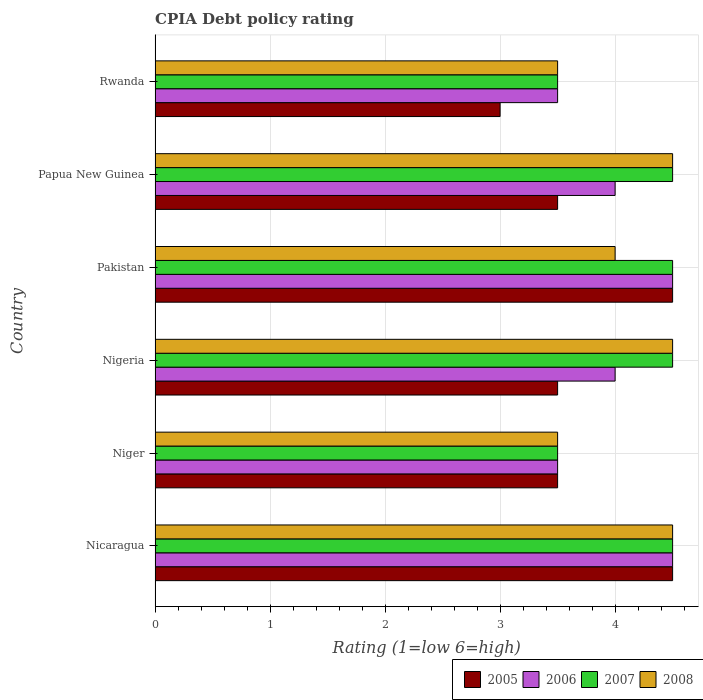How many groups of bars are there?
Provide a short and direct response. 6. Are the number of bars per tick equal to the number of legend labels?
Your answer should be very brief. Yes. Are the number of bars on each tick of the Y-axis equal?
Keep it short and to the point. Yes. How many bars are there on the 4th tick from the top?
Ensure brevity in your answer.  4. What is the label of the 1st group of bars from the top?
Offer a very short reply. Rwanda. In how many cases, is the number of bars for a given country not equal to the number of legend labels?
Your answer should be compact. 0. Across all countries, what is the minimum CPIA rating in 2005?
Your answer should be compact. 3. In which country was the CPIA rating in 2007 maximum?
Your answer should be very brief. Nicaragua. In which country was the CPIA rating in 2006 minimum?
Provide a succinct answer. Niger. What is the average CPIA rating in 2008 per country?
Make the answer very short. 4.08. What is the difference between the CPIA rating in 2006 and CPIA rating in 2005 in Nicaragua?
Provide a succinct answer. 0. In how many countries, is the CPIA rating in 2006 greater than 0.2 ?
Offer a very short reply. 6. What is the ratio of the CPIA rating in 2006 in Papua New Guinea to that in Rwanda?
Make the answer very short. 1.14. Is the CPIA rating in 2006 in Nicaragua less than that in Papua New Guinea?
Make the answer very short. No. Is the difference between the CPIA rating in 2006 in Nigeria and Pakistan greater than the difference between the CPIA rating in 2005 in Nigeria and Pakistan?
Your answer should be compact. Yes. What is the difference between the highest and the lowest CPIA rating in 2007?
Ensure brevity in your answer.  1. Is the sum of the CPIA rating in 2005 in Niger and Nigeria greater than the maximum CPIA rating in 2007 across all countries?
Keep it short and to the point. Yes. What does the 1st bar from the top in Niger represents?
Your answer should be compact. 2008. What does the 4th bar from the bottom in Nigeria represents?
Keep it short and to the point. 2008. Is it the case that in every country, the sum of the CPIA rating in 2006 and CPIA rating in 2007 is greater than the CPIA rating in 2005?
Make the answer very short. Yes. Are all the bars in the graph horizontal?
Your answer should be very brief. Yes. How many countries are there in the graph?
Offer a terse response. 6. Does the graph contain any zero values?
Your response must be concise. No. Where does the legend appear in the graph?
Keep it short and to the point. Bottom right. What is the title of the graph?
Offer a very short reply. CPIA Debt policy rating. What is the label or title of the X-axis?
Give a very brief answer. Rating (1=low 6=high). What is the Rating (1=low 6=high) in 2005 in Nigeria?
Make the answer very short. 3.5. What is the Rating (1=low 6=high) of 2007 in Nigeria?
Provide a short and direct response. 4.5. What is the Rating (1=low 6=high) of 2006 in Pakistan?
Ensure brevity in your answer.  4.5. What is the Rating (1=low 6=high) in 2007 in Pakistan?
Ensure brevity in your answer.  4.5. What is the Rating (1=low 6=high) in 2007 in Papua New Guinea?
Make the answer very short. 4.5. What is the Rating (1=low 6=high) in 2006 in Rwanda?
Provide a succinct answer. 3.5. What is the Rating (1=low 6=high) of 2007 in Rwanda?
Ensure brevity in your answer.  3.5. Across all countries, what is the maximum Rating (1=low 6=high) in 2005?
Your answer should be very brief. 4.5. Across all countries, what is the maximum Rating (1=low 6=high) in 2006?
Keep it short and to the point. 4.5. Across all countries, what is the maximum Rating (1=low 6=high) in 2007?
Provide a short and direct response. 4.5. Across all countries, what is the maximum Rating (1=low 6=high) of 2008?
Give a very brief answer. 4.5. Across all countries, what is the minimum Rating (1=low 6=high) in 2005?
Make the answer very short. 3. Across all countries, what is the minimum Rating (1=low 6=high) in 2006?
Your answer should be compact. 3.5. Across all countries, what is the minimum Rating (1=low 6=high) in 2007?
Your answer should be very brief. 3.5. Across all countries, what is the minimum Rating (1=low 6=high) of 2008?
Your answer should be very brief. 3.5. What is the total Rating (1=low 6=high) of 2006 in the graph?
Provide a succinct answer. 24. What is the total Rating (1=low 6=high) in 2007 in the graph?
Provide a succinct answer. 25. What is the difference between the Rating (1=low 6=high) in 2005 in Nicaragua and that in Niger?
Your response must be concise. 1. What is the difference between the Rating (1=low 6=high) in 2007 in Nicaragua and that in Niger?
Give a very brief answer. 1. What is the difference between the Rating (1=low 6=high) in 2006 in Nicaragua and that in Nigeria?
Your answer should be compact. 0.5. What is the difference between the Rating (1=low 6=high) in 2008 in Nicaragua and that in Nigeria?
Ensure brevity in your answer.  0. What is the difference between the Rating (1=low 6=high) in 2006 in Nicaragua and that in Pakistan?
Keep it short and to the point. 0. What is the difference between the Rating (1=low 6=high) of 2007 in Nicaragua and that in Pakistan?
Keep it short and to the point. 0. What is the difference between the Rating (1=low 6=high) of 2008 in Nicaragua and that in Pakistan?
Keep it short and to the point. 0.5. What is the difference between the Rating (1=low 6=high) in 2005 in Nicaragua and that in Papua New Guinea?
Provide a short and direct response. 1. What is the difference between the Rating (1=low 6=high) of 2008 in Nicaragua and that in Papua New Guinea?
Make the answer very short. 0. What is the difference between the Rating (1=low 6=high) in 2005 in Nicaragua and that in Rwanda?
Provide a succinct answer. 1.5. What is the difference between the Rating (1=low 6=high) of 2007 in Nicaragua and that in Rwanda?
Your response must be concise. 1. What is the difference between the Rating (1=low 6=high) in 2008 in Nicaragua and that in Rwanda?
Give a very brief answer. 1. What is the difference between the Rating (1=low 6=high) of 2006 in Niger and that in Nigeria?
Your response must be concise. -0.5. What is the difference between the Rating (1=low 6=high) of 2008 in Niger and that in Nigeria?
Your answer should be very brief. -1. What is the difference between the Rating (1=low 6=high) in 2006 in Niger and that in Pakistan?
Provide a short and direct response. -1. What is the difference between the Rating (1=low 6=high) of 2007 in Niger and that in Pakistan?
Your answer should be very brief. -1. What is the difference between the Rating (1=low 6=high) of 2006 in Niger and that in Papua New Guinea?
Provide a short and direct response. -0.5. What is the difference between the Rating (1=low 6=high) of 2007 in Niger and that in Papua New Guinea?
Provide a succinct answer. -1. What is the difference between the Rating (1=low 6=high) in 2005 in Niger and that in Rwanda?
Offer a terse response. 0.5. What is the difference between the Rating (1=low 6=high) of 2007 in Niger and that in Rwanda?
Ensure brevity in your answer.  0. What is the difference between the Rating (1=low 6=high) of 2006 in Nigeria and that in Pakistan?
Ensure brevity in your answer.  -0.5. What is the difference between the Rating (1=low 6=high) of 2007 in Nigeria and that in Pakistan?
Provide a short and direct response. 0. What is the difference between the Rating (1=low 6=high) of 2008 in Nigeria and that in Pakistan?
Your answer should be compact. 0.5. What is the difference between the Rating (1=low 6=high) in 2007 in Nigeria and that in Papua New Guinea?
Keep it short and to the point. 0. What is the difference between the Rating (1=low 6=high) of 2008 in Nigeria and that in Papua New Guinea?
Give a very brief answer. 0. What is the difference between the Rating (1=low 6=high) of 2005 in Nigeria and that in Rwanda?
Offer a terse response. 0.5. What is the difference between the Rating (1=low 6=high) in 2006 in Nigeria and that in Rwanda?
Keep it short and to the point. 0.5. What is the difference between the Rating (1=low 6=high) of 2007 in Nigeria and that in Rwanda?
Ensure brevity in your answer.  1. What is the difference between the Rating (1=low 6=high) of 2008 in Nigeria and that in Rwanda?
Offer a terse response. 1. What is the difference between the Rating (1=low 6=high) of 2007 in Pakistan and that in Papua New Guinea?
Keep it short and to the point. 0. What is the difference between the Rating (1=low 6=high) in 2008 in Pakistan and that in Papua New Guinea?
Make the answer very short. -0.5. What is the difference between the Rating (1=low 6=high) in 2005 in Pakistan and that in Rwanda?
Your answer should be very brief. 1.5. What is the difference between the Rating (1=low 6=high) of 2006 in Pakistan and that in Rwanda?
Offer a terse response. 1. What is the difference between the Rating (1=low 6=high) in 2007 in Pakistan and that in Rwanda?
Keep it short and to the point. 1. What is the difference between the Rating (1=low 6=high) in 2008 in Pakistan and that in Rwanda?
Ensure brevity in your answer.  0.5. What is the difference between the Rating (1=low 6=high) in 2006 in Papua New Guinea and that in Rwanda?
Offer a terse response. 0.5. What is the difference between the Rating (1=low 6=high) of 2007 in Papua New Guinea and that in Rwanda?
Offer a terse response. 1. What is the difference between the Rating (1=low 6=high) in 2008 in Papua New Guinea and that in Rwanda?
Give a very brief answer. 1. What is the difference between the Rating (1=low 6=high) of 2005 in Nicaragua and the Rating (1=low 6=high) of 2007 in Niger?
Provide a short and direct response. 1. What is the difference between the Rating (1=low 6=high) in 2005 in Nicaragua and the Rating (1=low 6=high) in 2008 in Niger?
Your answer should be very brief. 1. What is the difference between the Rating (1=low 6=high) in 2006 in Nicaragua and the Rating (1=low 6=high) in 2007 in Niger?
Ensure brevity in your answer.  1. What is the difference between the Rating (1=low 6=high) in 2007 in Nicaragua and the Rating (1=low 6=high) in 2008 in Niger?
Your answer should be compact. 1. What is the difference between the Rating (1=low 6=high) of 2005 in Nicaragua and the Rating (1=low 6=high) of 2008 in Nigeria?
Provide a short and direct response. 0. What is the difference between the Rating (1=low 6=high) in 2006 in Nicaragua and the Rating (1=low 6=high) in 2007 in Nigeria?
Ensure brevity in your answer.  0. What is the difference between the Rating (1=low 6=high) of 2007 in Nicaragua and the Rating (1=low 6=high) of 2008 in Nigeria?
Your answer should be very brief. 0. What is the difference between the Rating (1=low 6=high) in 2005 in Nicaragua and the Rating (1=low 6=high) in 2007 in Pakistan?
Provide a short and direct response. 0. What is the difference between the Rating (1=low 6=high) in 2005 in Nicaragua and the Rating (1=low 6=high) in 2008 in Pakistan?
Your response must be concise. 0.5. What is the difference between the Rating (1=low 6=high) in 2005 in Nicaragua and the Rating (1=low 6=high) in 2007 in Papua New Guinea?
Your response must be concise. 0. What is the difference between the Rating (1=low 6=high) of 2006 in Nicaragua and the Rating (1=low 6=high) of 2008 in Papua New Guinea?
Make the answer very short. 0. What is the difference between the Rating (1=low 6=high) in 2005 in Nicaragua and the Rating (1=low 6=high) in 2006 in Rwanda?
Provide a succinct answer. 1. What is the difference between the Rating (1=low 6=high) of 2006 in Nicaragua and the Rating (1=low 6=high) of 2007 in Rwanda?
Provide a short and direct response. 1. What is the difference between the Rating (1=low 6=high) of 2007 in Nicaragua and the Rating (1=low 6=high) of 2008 in Rwanda?
Provide a succinct answer. 1. What is the difference between the Rating (1=low 6=high) of 2005 in Niger and the Rating (1=low 6=high) of 2007 in Nigeria?
Offer a terse response. -1. What is the difference between the Rating (1=low 6=high) in 2006 in Niger and the Rating (1=low 6=high) in 2008 in Nigeria?
Your response must be concise. -1. What is the difference between the Rating (1=low 6=high) of 2007 in Niger and the Rating (1=low 6=high) of 2008 in Nigeria?
Your answer should be compact. -1. What is the difference between the Rating (1=low 6=high) of 2005 in Niger and the Rating (1=low 6=high) of 2007 in Pakistan?
Your response must be concise. -1. What is the difference between the Rating (1=low 6=high) of 2005 in Niger and the Rating (1=low 6=high) of 2008 in Pakistan?
Give a very brief answer. -0.5. What is the difference between the Rating (1=low 6=high) in 2006 in Niger and the Rating (1=low 6=high) in 2008 in Pakistan?
Offer a terse response. -0.5. What is the difference between the Rating (1=low 6=high) of 2007 in Niger and the Rating (1=low 6=high) of 2008 in Pakistan?
Your response must be concise. -0.5. What is the difference between the Rating (1=low 6=high) of 2005 in Niger and the Rating (1=low 6=high) of 2006 in Papua New Guinea?
Make the answer very short. -0.5. What is the difference between the Rating (1=low 6=high) in 2005 in Niger and the Rating (1=low 6=high) in 2007 in Papua New Guinea?
Keep it short and to the point. -1. What is the difference between the Rating (1=low 6=high) of 2005 in Niger and the Rating (1=low 6=high) of 2008 in Papua New Guinea?
Provide a succinct answer. -1. What is the difference between the Rating (1=low 6=high) of 2006 in Niger and the Rating (1=low 6=high) of 2008 in Papua New Guinea?
Your answer should be very brief. -1. What is the difference between the Rating (1=low 6=high) of 2007 in Niger and the Rating (1=low 6=high) of 2008 in Papua New Guinea?
Your answer should be very brief. -1. What is the difference between the Rating (1=low 6=high) in 2005 in Niger and the Rating (1=low 6=high) in 2007 in Rwanda?
Your answer should be very brief. 0. What is the difference between the Rating (1=low 6=high) of 2006 in Niger and the Rating (1=low 6=high) of 2008 in Rwanda?
Your answer should be compact. 0. What is the difference between the Rating (1=low 6=high) in 2007 in Niger and the Rating (1=low 6=high) in 2008 in Rwanda?
Your answer should be compact. 0. What is the difference between the Rating (1=low 6=high) of 2005 in Nigeria and the Rating (1=low 6=high) of 2007 in Pakistan?
Provide a succinct answer. -1. What is the difference between the Rating (1=low 6=high) of 2006 in Nigeria and the Rating (1=low 6=high) of 2007 in Pakistan?
Give a very brief answer. -0.5. What is the difference between the Rating (1=low 6=high) of 2006 in Nigeria and the Rating (1=low 6=high) of 2008 in Pakistan?
Provide a succinct answer. 0. What is the difference between the Rating (1=low 6=high) of 2005 in Nigeria and the Rating (1=low 6=high) of 2006 in Papua New Guinea?
Make the answer very short. -0.5. What is the difference between the Rating (1=low 6=high) of 2005 in Nigeria and the Rating (1=low 6=high) of 2007 in Papua New Guinea?
Your response must be concise. -1. What is the difference between the Rating (1=low 6=high) of 2006 in Nigeria and the Rating (1=low 6=high) of 2007 in Papua New Guinea?
Your answer should be compact. -0.5. What is the difference between the Rating (1=low 6=high) of 2005 in Nigeria and the Rating (1=low 6=high) of 2006 in Rwanda?
Provide a succinct answer. 0. What is the difference between the Rating (1=low 6=high) in 2006 in Nigeria and the Rating (1=low 6=high) in 2008 in Rwanda?
Give a very brief answer. 0.5. What is the difference between the Rating (1=low 6=high) of 2005 in Pakistan and the Rating (1=low 6=high) of 2007 in Papua New Guinea?
Give a very brief answer. 0. What is the difference between the Rating (1=low 6=high) in 2005 in Pakistan and the Rating (1=low 6=high) in 2008 in Papua New Guinea?
Ensure brevity in your answer.  0. What is the difference between the Rating (1=low 6=high) in 2006 in Pakistan and the Rating (1=low 6=high) in 2007 in Papua New Guinea?
Make the answer very short. 0. What is the difference between the Rating (1=low 6=high) of 2006 in Pakistan and the Rating (1=low 6=high) of 2008 in Papua New Guinea?
Your answer should be very brief. 0. What is the difference between the Rating (1=low 6=high) of 2005 in Pakistan and the Rating (1=low 6=high) of 2007 in Rwanda?
Your answer should be very brief. 1. What is the difference between the Rating (1=low 6=high) in 2005 in Pakistan and the Rating (1=low 6=high) in 2008 in Rwanda?
Provide a short and direct response. 1. What is the difference between the Rating (1=low 6=high) of 2006 in Pakistan and the Rating (1=low 6=high) of 2008 in Rwanda?
Make the answer very short. 1. What is the difference between the Rating (1=low 6=high) in 2006 in Papua New Guinea and the Rating (1=low 6=high) in 2007 in Rwanda?
Offer a terse response. 0.5. What is the average Rating (1=low 6=high) in 2005 per country?
Keep it short and to the point. 3.75. What is the average Rating (1=low 6=high) in 2006 per country?
Your answer should be very brief. 4. What is the average Rating (1=low 6=high) in 2007 per country?
Your answer should be compact. 4.17. What is the average Rating (1=low 6=high) in 2008 per country?
Offer a terse response. 4.08. What is the difference between the Rating (1=low 6=high) of 2005 and Rating (1=low 6=high) of 2006 in Nicaragua?
Provide a succinct answer. 0. What is the difference between the Rating (1=low 6=high) in 2005 and Rating (1=low 6=high) in 2007 in Nicaragua?
Ensure brevity in your answer.  0. What is the difference between the Rating (1=low 6=high) of 2005 and Rating (1=low 6=high) of 2008 in Nicaragua?
Make the answer very short. 0. What is the difference between the Rating (1=low 6=high) of 2007 and Rating (1=low 6=high) of 2008 in Nicaragua?
Your answer should be very brief. 0. What is the difference between the Rating (1=low 6=high) in 2005 and Rating (1=low 6=high) in 2006 in Niger?
Ensure brevity in your answer.  0. What is the difference between the Rating (1=low 6=high) in 2005 and Rating (1=low 6=high) in 2007 in Niger?
Give a very brief answer. 0. What is the difference between the Rating (1=low 6=high) of 2006 and Rating (1=low 6=high) of 2007 in Niger?
Your answer should be very brief. 0. What is the difference between the Rating (1=low 6=high) of 2006 and Rating (1=low 6=high) of 2008 in Niger?
Make the answer very short. 0. What is the difference between the Rating (1=low 6=high) in 2005 and Rating (1=low 6=high) in 2006 in Nigeria?
Your answer should be compact. -0.5. What is the difference between the Rating (1=low 6=high) of 2005 and Rating (1=low 6=high) of 2007 in Nigeria?
Your response must be concise. -1. What is the difference between the Rating (1=low 6=high) in 2005 and Rating (1=low 6=high) in 2008 in Nigeria?
Offer a very short reply. -1. What is the difference between the Rating (1=low 6=high) of 2006 and Rating (1=low 6=high) of 2007 in Nigeria?
Ensure brevity in your answer.  -0.5. What is the difference between the Rating (1=low 6=high) of 2006 and Rating (1=low 6=high) of 2008 in Nigeria?
Provide a succinct answer. -0.5. What is the difference between the Rating (1=low 6=high) of 2005 and Rating (1=low 6=high) of 2006 in Pakistan?
Your answer should be very brief. 0. What is the difference between the Rating (1=low 6=high) of 2005 and Rating (1=low 6=high) of 2007 in Pakistan?
Offer a very short reply. 0. What is the difference between the Rating (1=low 6=high) in 2006 and Rating (1=low 6=high) in 2007 in Pakistan?
Provide a succinct answer. 0. What is the difference between the Rating (1=low 6=high) in 2007 and Rating (1=low 6=high) in 2008 in Pakistan?
Make the answer very short. 0.5. What is the difference between the Rating (1=low 6=high) of 2005 and Rating (1=low 6=high) of 2008 in Papua New Guinea?
Give a very brief answer. -1. What is the difference between the Rating (1=low 6=high) in 2006 and Rating (1=low 6=high) in 2007 in Papua New Guinea?
Give a very brief answer. -0.5. What is the difference between the Rating (1=low 6=high) of 2005 and Rating (1=low 6=high) of 2006 in Rwanda?
Provide a succinct answer. -0.5. What is the difference between the Rating (1=low 6=high) of 2005 and Rating (1=low 6=high) of 2007 in Rwanda?
Provide a succinct answer. -0.5. What is the difference between the Rating (1=low 6=high) of 2005 and Rating (1=low 6=high) of 2008 in Rwanda?
Offer a terse response. -0.5. What is the difference between the Rating (1=low 6=high) of 2007 and Rating (1=low 6=high) of 2008 in Rwanda?
Provide a short and direct response. 0. What is the ratio of the Rating (1=low 6=high) of 2007 in Nicaragua to that in Nigeria?
Provide a short and direct response. 1. What is the ratio of the Rating (1=low 6=high) in 2005 in Nicaragua to that in Pakistan?
Ensure brevity in your answer.  1. What is the ratio of the Rating (1=low 6=high) of 2006 in Nicaragua to that in Pakistan?
Offer a very short reply. 1. What is the ratio of the Rating (1=low 6=high) in 2007 in Nicaragua to that in Pakistan?
Your answer should be very brief. 1. What is the ratio of the Rating (1=low 6=high) of 2005 in Nicaragua to that in Papua New Guinea?
Provide a short and direct response. 1.29. What is the ratio of the Rating (1=low 6=high) in 2006 in Nicaragua to that in Papua New Guinea?
Your answer should be compact. 1.12. What is the ratio of the Rating (1=low 6=high) in 2007 in Nicaragua to that in Rwanda?
Make the answer very short. 1.29. What is the ratio of the Rating (1=low 6=high) in 2007 in Niger to that in Nigeria?
Provide a succinct answer. 0.78. What is the ratio of the Rating (1=low 6=high) of 2005 in Niger to that in Pakistan?
Make the answer very short. 0.78. What is the ratio of the Rating (1=low 6=high) in 2007 in Niger to that in Pakistan?
Your response must be concise. 0.78. What is the ratio of the Rating (1=low 6=high) in 2005 in Niger to that in Papua New Guinea?
Give a very brief answer. 1. What is the ratio of the Rating (1=low 6=high) in 2006 in Niger to that in Rwanda?
Make the answer very short. 1. What is the ratio of the Rating (1=low 6=high) of 2006 in Nigeria to that in Pakistan?
Provide a succinct answer. 0.89. What is the ratio of the Rating (1=low 6=high) in 2007 in Nigeria to that in Pakistan?
Ensure brevity in your answer.  1. What is the ratio of the Rating (1=low 6=high) in 2008 in Nigeria to that in Pakistan?
Ensure brevity in your answer.  1.12. What is the ratio of the Rating (1=low 6=high) in 2007 in Nigeria to that in Papua New Guinea?
Offer a terse response. 1. What is the ratio of the Rating (1=low 6=high) of 2005 in Nigeria to that in Rwanda?
Keep it short and to the point. 1.17. What is the ratio of the Rating (1=low 6=high) of 2006 in Nigeria to that in Rwanda?
Keep it short and to the point. 1.14. What is the ratio of the Rating (1=low 6=high) in 2007 in Nigeria to that in Rwanda?
Give a very brief answer. 1.29. What is the ratio of the Rating (1=low 6=high) of 2008 in Nigeria to that in Rwanda?
Your response must be concise. 1.29. What is the ratio of the Rating (1=low 6=high) of 2005 in Pakistan to that in Papua New Guinea?
Provide a short and direct response. 1.29. What is the ratio of the Rating (1=low 6=high) of 2006 in Pakistan to that in Papua New Guinea?
Give a very brief answer. 1.12. What is the ratio of the Rating (1=low 6=high) in 2008 in Pakistan to that in Papua New Guinea?
Offer a very short reply. 0.89. What is the ratio of the Rating (1=low 6=high) of 2006 in Pakistan to that in Rwanda?
Make the answer very short. 1.29. What is the ratio of the Rating (1=low 6=high) in 2007 in Pakistan to that in Rwanda?
Provide a succinct answer. 1.29. What is the ratio of the Rating (1=low 6=high) of 2008 in Pakistan to that in Rwanda?
Make the answer very short. 1.14. What is the ratio of the Rating (1=low 6=high) in 2006 in Papua New Guinea to that in Rwanda?
Your response must be concise. 1.14. What is the ratio of the Rating (1=low 6=high) of 2007 in Papua New Guinea to that in Rwanda?
Give a very brief answer. 1.29. What is the ratio of the Rating (1=low 6=high) of 2008 in Papua New Guinea to that in Rwanda?
Provide a succinct answer. 1.29. What is the difference between the highest and the second highest Rating (1=low 6=high) of 2006?
Provide a short and direct response. 0. What is the difference between the highest and the second highest Rating (1=low 6=high) in 2007?
Provide a short and direct response. 0. What is the difference between the highest and the second highest Rating (1=low 6=high) in 2008?
Provide a short and direct response. 0. 